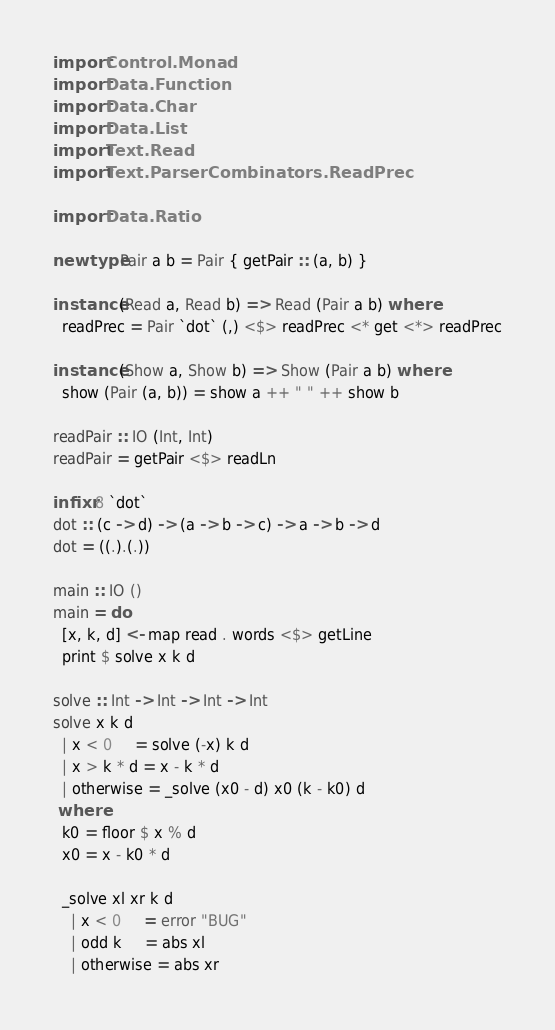Convert code to text. <code><loc_0><loc_0><loc_500><loc_500><_Haskell_>import Control.Monad
import Data.Function
import Data.Char
import Data.List
import Text.Read
import Text.ParserCombinators.ReadPrec

import Data.Ratio

newtype Pair a b = Pair { getPair :: (a, b) }

instance (Read a, Read b) => Read (Pair a b) where
  readPrec = Pair `dot` (,) <$> readPrec <* get <*> readPrec

instance (Show a, Show b) => Show (Pair a b) where
  show (Pair (a, b)) = show a ++ " " ++ show b

readPair :: IO (Int, Int)
readPair = getPair <$> readLn

infixr 8 `dot`
dot :: (c -> d) -> (a -> b -> c) -> a -> b -> d
dot = ((.).(.))

main :: IO ()
main = do
  [x, k, d] <- map read . words <$> getLine
  print $ solve x k d

solve :: Int -> Int -> Int -> Int
solve x k d
  | x < 0     = solve (-x) k d
  | x > k * d = x - k * d
  | otherwise = _solve (x0 - d) x0 (k - k0) d
 where
  k0 = floor $ x % d
  x0 = x - k0 * d

  _solve xl xr k d
    | x < 0     = error "BUG"
    | odd k     = abs xl
    | otherwise = abs xr
</code> 